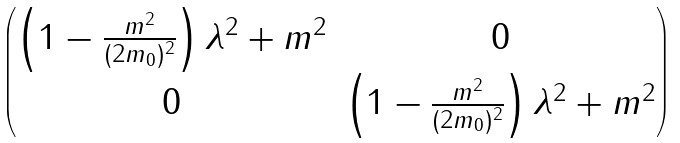<formula> <loc_0><loc_0><loc_500><loc_500>\begin{pmatrix} \left ( 1 - \frac { m ^ { 2 } } { ( 2 m _ { 0 } ) ^ { 2 } } \right ) \lambda ^ { 2 } + m ^ { 2 } & 0 \\ 0 & \left ( 1 - \frac { m ^ { 2 } } { ( 2 m _ { 0 } ) ^ { 2 } } \right ) \lambda ^ { 2 } + m ^ { 2 } \end{pmatrix}</formula> 